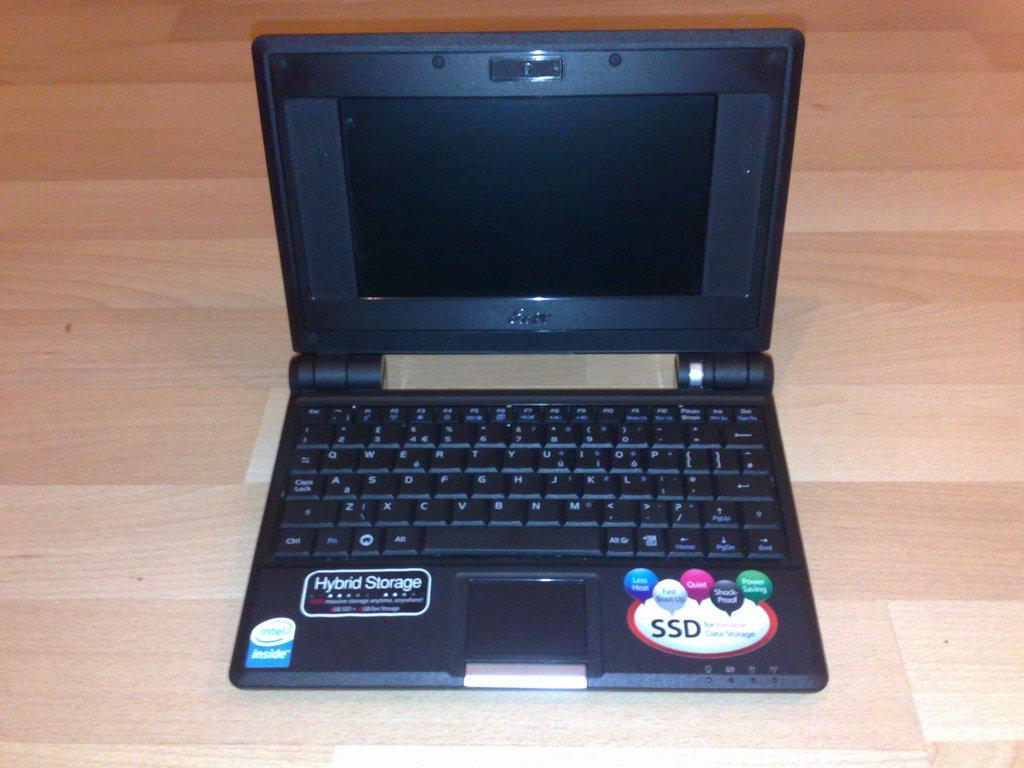<image>
Describe the image concisely. The laptop has Hybrid storage and a SSD disk. 